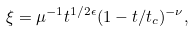<formula> <loc_0><loc_0><loc_500><loc_500>\xi = \mu ^ { - 1 } t ^ { 1 / 2 \epsilon } ( 1 - t / t _ { c } ) ^ { - \nu } ,</formula> 